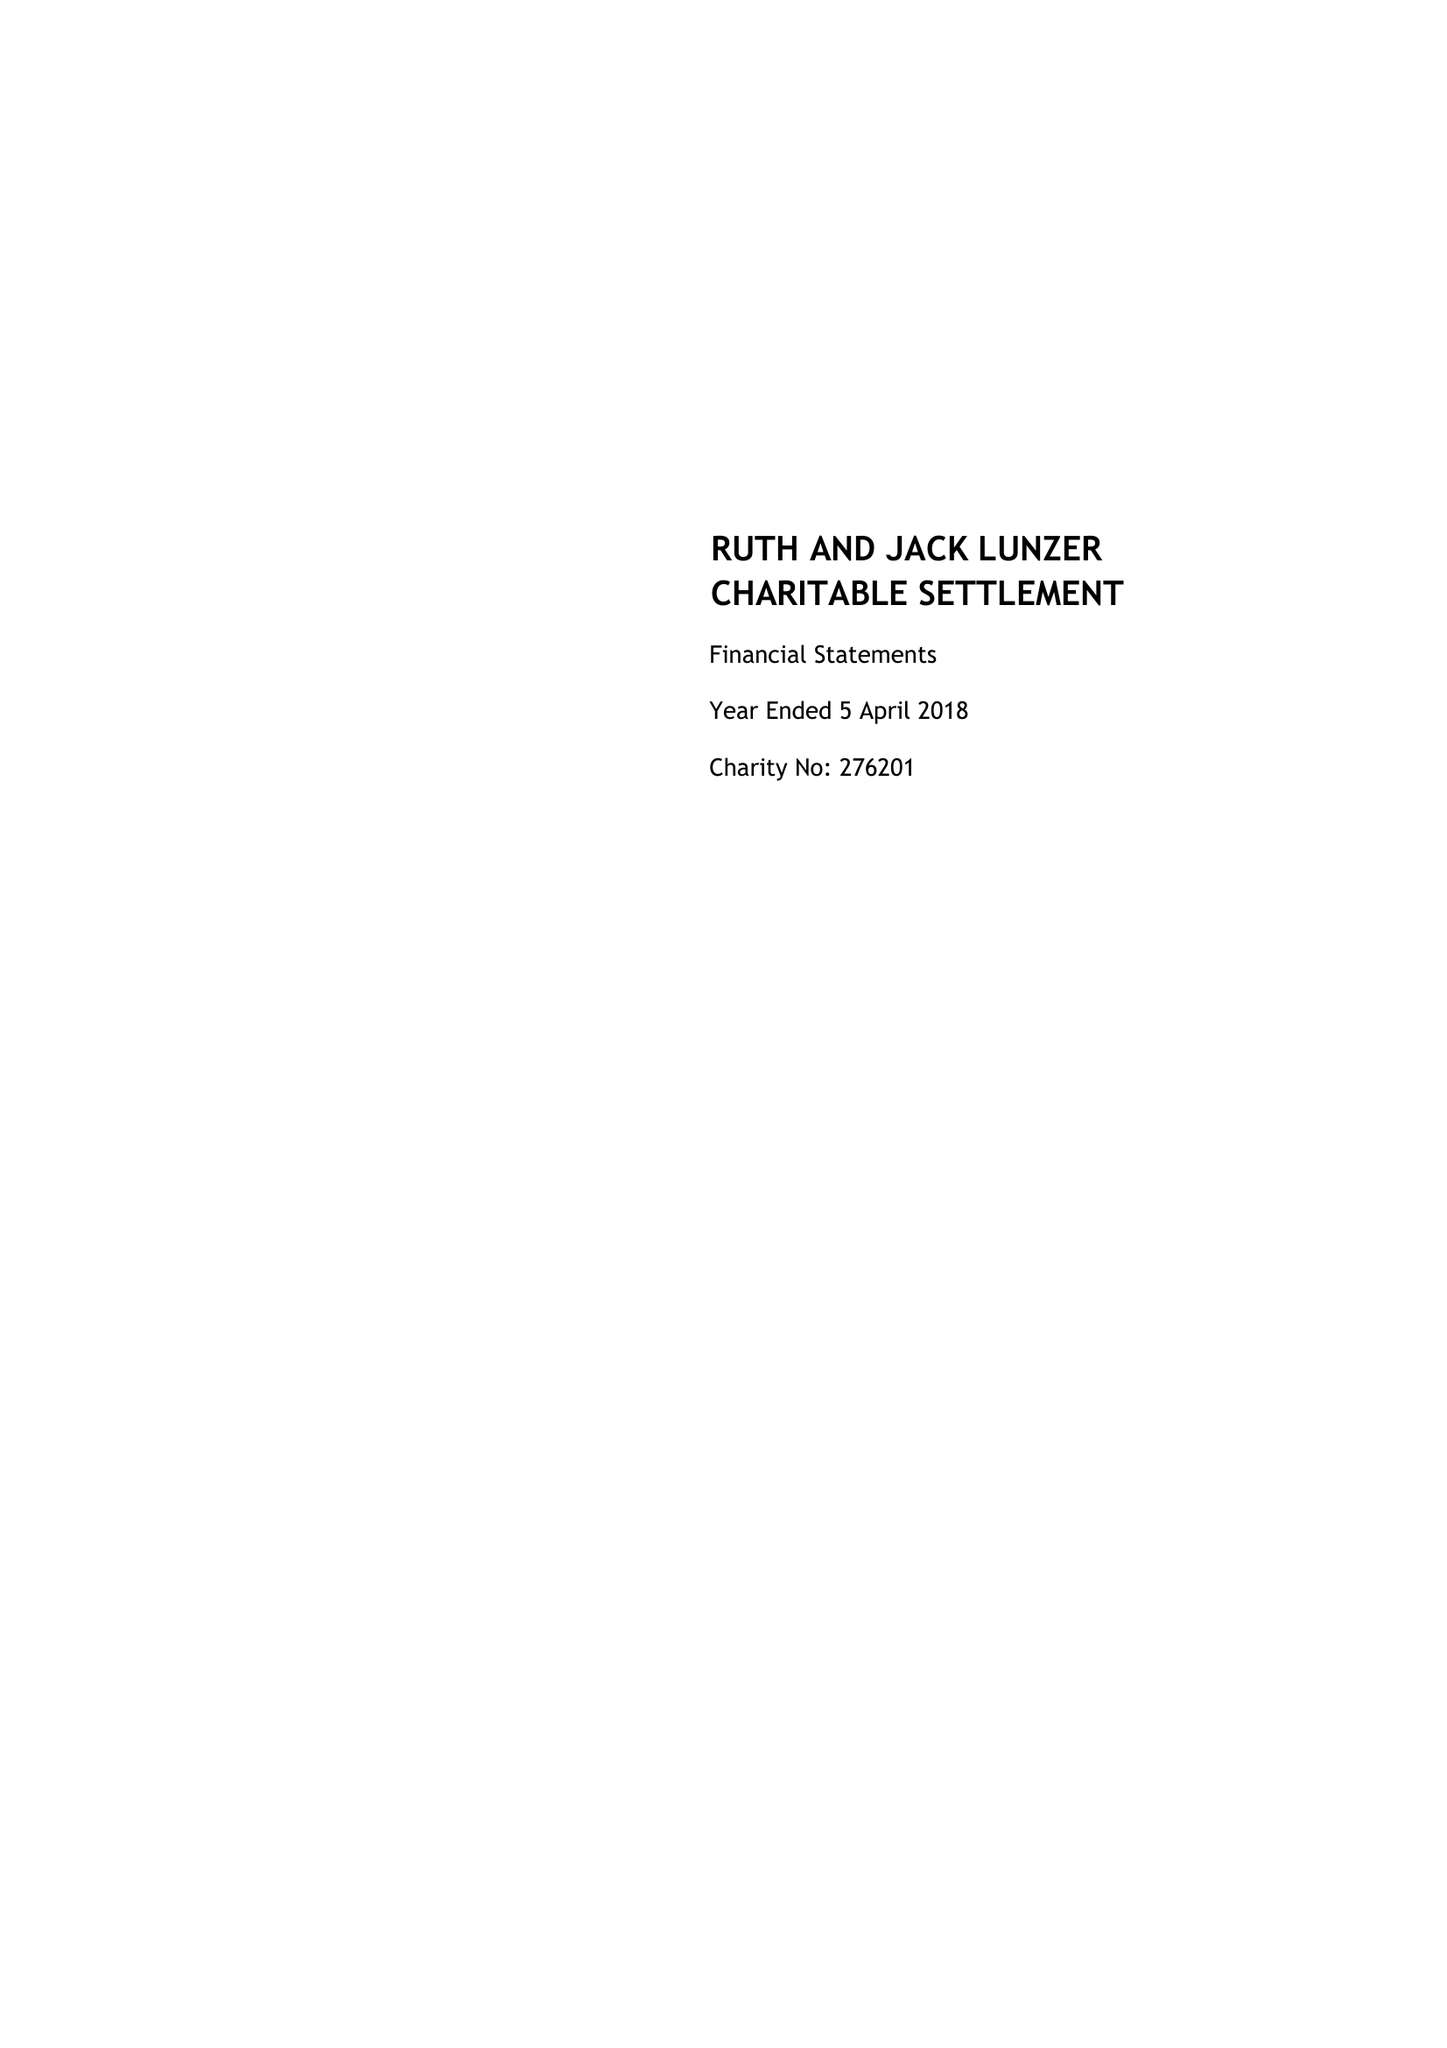What is the value for the charity_name?
Answer the question using a single word or phrase. The Ruth and Jack Lunzer Charitable Trust 